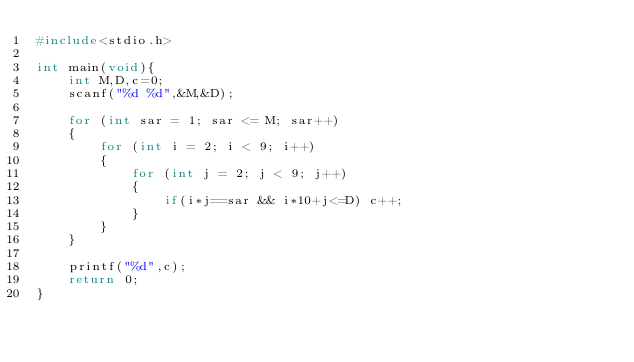Convert code to text. <code><loc_0><loc_0><loc_500><loc_500><_C_>#include<stdio.h>

int main(void){
    int M,D,c=0;
    scanf("%d %d",&M,&D);

    for (int sar = 1; sar <= M; sar++)
    {
        for (int i = 2; i < 9; i++)
        {
            for (int j = 2; j < 9; j++)
            {
                if(i*j==sar && i*10+j<=D) c++;
            }        
        }
    }
    
    printf("%d",c);
    return 0;
}</code> 